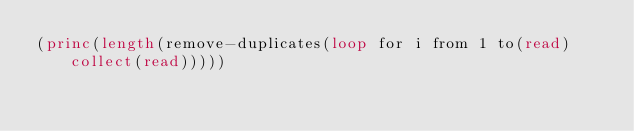<code> <loc_0><loc_0><loc_500><loc_500><_Lisp_>(princ(length(remove-duplicates(loop for i from 1 to(read)collect(read)))))</code> 